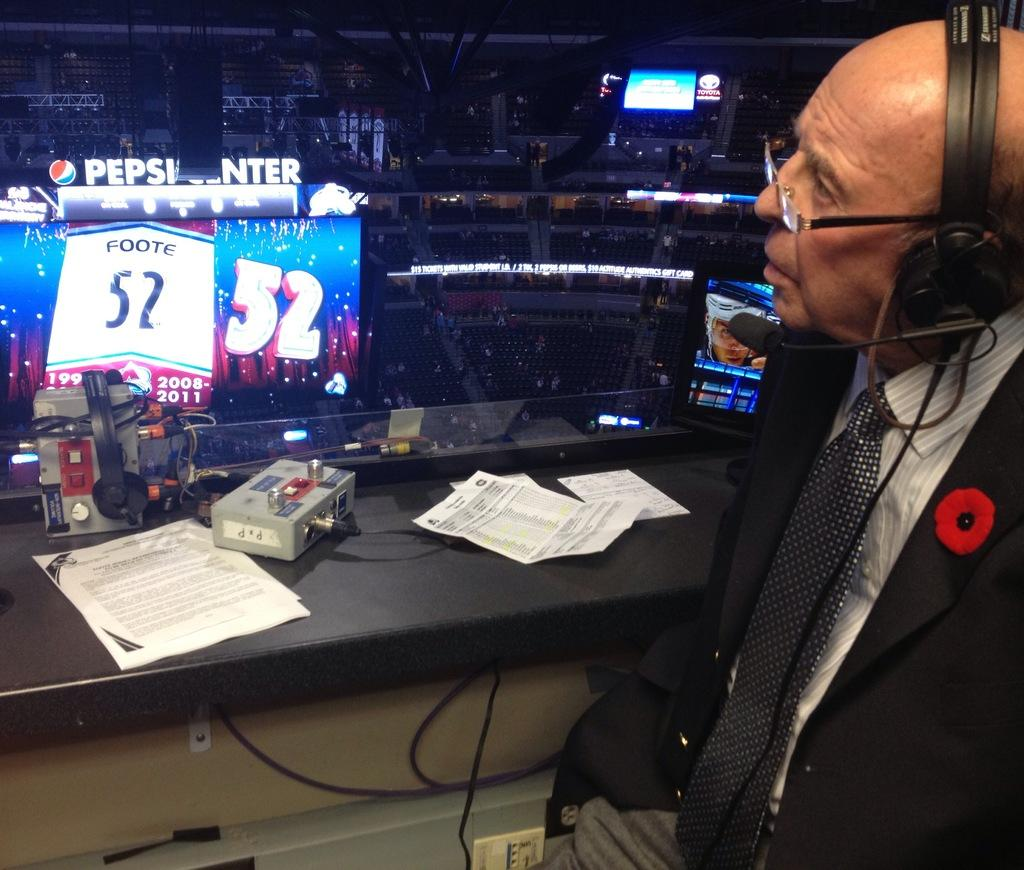Provide a one-sentence caption for the provided image. A sports caster looks out over the large Pepsi Center stadium. 